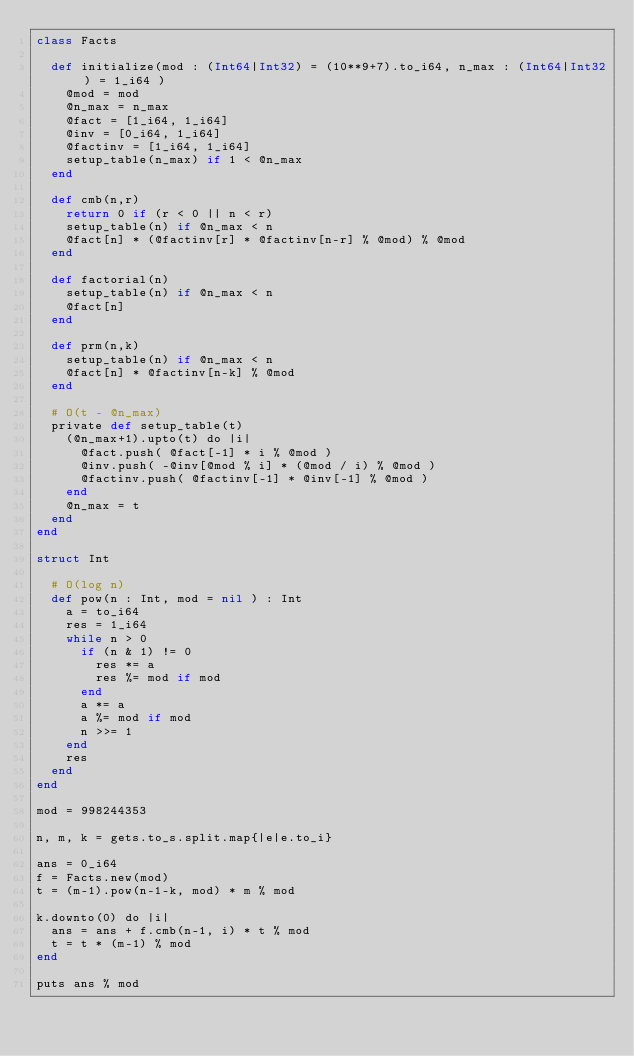Convert code to text. <code><loc_0><loc_0><loc_500><loc_500><_Crystal_>class Facts

  def initialize(mod : (Int64|Int32) = (10**9+7).to_i64, n_max : (Int64|Int32) = 1_i64 )
    @mod = mod
    @n_max = n_max
    @fact = [1_i64, 1_i64]
    @inv = [0_i64, 1_i64]
    @factinv = [1_i64, 1_i64]
    setup_table(n_max) if 1 < @n_max
  end

  def cmb(n,r)
    return 0 if (r < 0 || n < r)
    setup_table(n) if @n_max < n
    @fact[n] * (@factinv[r] * @factinv[n-r] % @mod) % @mod
  end

  def factorial(n)
    setup_table(n) if @n_max < n
    @fact[n]
  end

  def prm(n,k)
    setup_table(n) if @n_max < n
    @fact[n] * @factinv[n-k] % @mod
  end

  # O(t - @n_max)
  private def setup_table(t)
    (@n_max+1).upto(t) do |i|
      @fact.push( @fact[-1] * i % @mod )
      @inv.push( -@inv[@mod % i] * (@mod / i) % @mod )
      @factinv.push( @factinv[-1] * @inv[-1] % @mod )
    end
    @n_max = t
  end
end

struct Int
  
  # O(log n)
  def pow(n : Int, mod = nil ) : Int
    a = to_i64
    res = 1_i64
    while n > 0
      if (n & 1) != 0
        res *= a
        res %= mod if mod
      end
      a *= a
      a %= mod if mod
      n >>= 1
    end
    res
  end
end

mod = 998244353
 
n, m, k = gets.to_s.split.map{|e|e.to_i}

ans = 0_i64
f = Facts.new(mod)
t = (m-1).pow(n-1-k, mod) * m % mod
 
k.downto(0) do |i|
  ans = ans + f.cmb(n-1, i) * t % mod
  t = t * (m-1) % mod
end
 
puts ans % mod</code> 